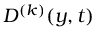<formula> <loc_0><loc_0><loc_500><loc_500>D ^ { ( k ) } ( y , t )</formula> 